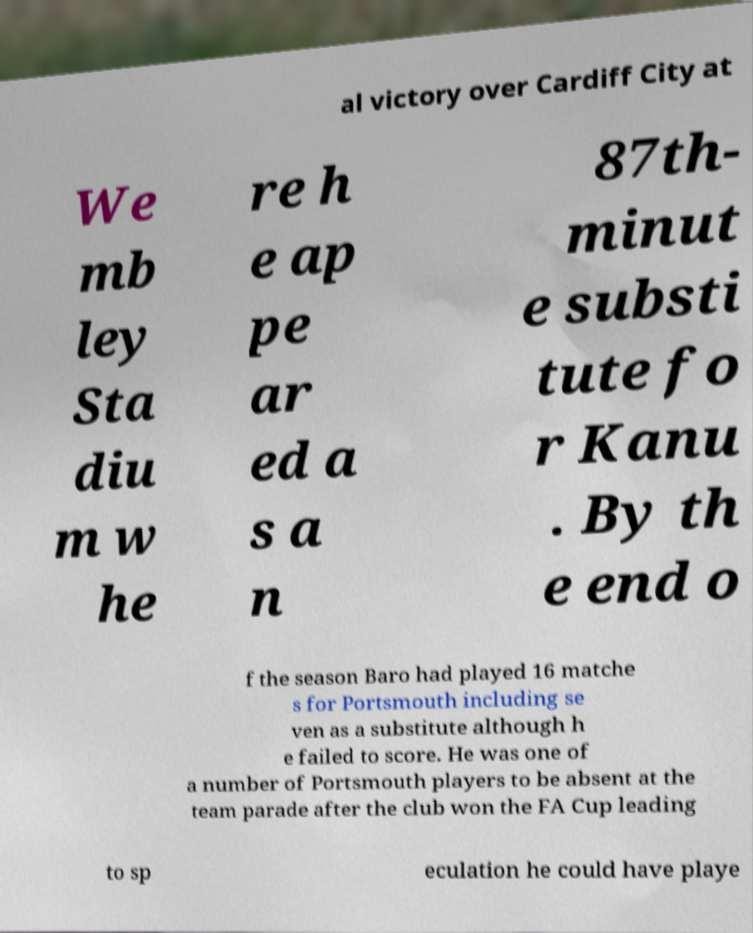Can you accurately transcribe the text from the provided image for me? al victory over Cardiff City at We mb ley Sta diu m w he re h e ap pe ar ed a s a n 87th- minut e substi tute fo r Kanu . By th e end o f the season Baro had played 16 matche s for Portsmouth including se ven as a substitute although h e failed to score. He was one of a number of Portsmouth players to be absent at the team parade after the club won the FA Cup leading to sp eculation he could have playe 